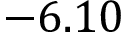Convert formula to latex. <formula><loc_0><loc_0><loc_500><loc_500>- 6 . 1 0</formula> 